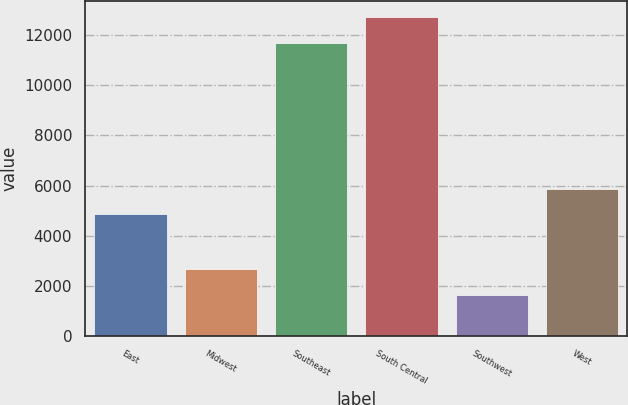Convert chart to OTSL. <chart><loc_0><loc_0><loc_500><loc_500><bar_chart><fcel>East<fcel>Midwest<fcel>Southeast<fcel>South Central<fcel>Southwest<fcel>West<nl><fcel>4859<fcel>2655.8<fcel>11703<fcel>12713.8<fcel>1645<fcel>5869.8<nl></chart> 